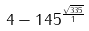<formula> <loc_0><loc_0><loc_500><loc_500>4 - 1 4 5 ^ { \frac { \sqrt { 3 3 5 } } { 1 } }</formula> 